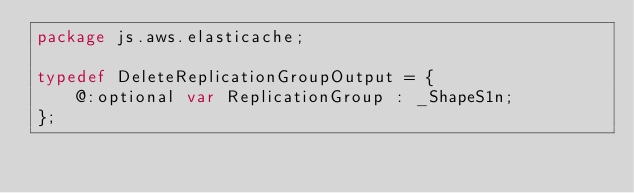<code> <loc_0><loc_0><loc_500><loc_500><_Haxe_>package js.aws.elasticache;

typedef DeleteReplicationGroupOutput = {
    @:optional var ReplicationGroup : _ShapeS1n;
};
</code> 